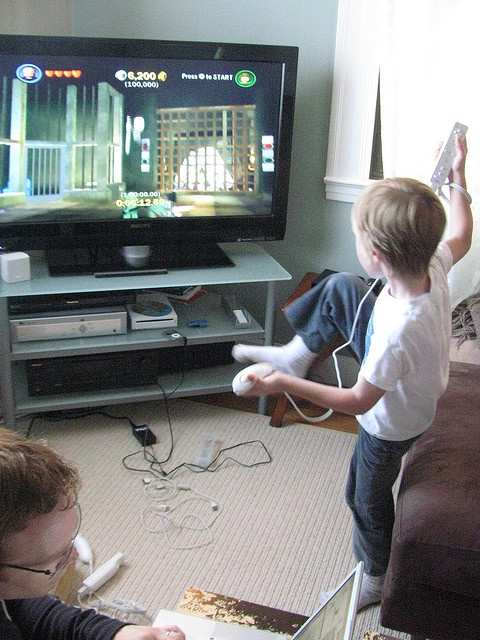Describe the objects in this image and their specific colors. I can see tv in gray, black, ivory, and blue tones, people in gray, darkgray, lightgray, and black tones, couch in gray and black tones, people in gray and black tones, and keyboard in gray and black tones in this image. 